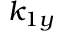<formula> <loc_0><loc_0><loc_500><loc_500>k _ { 1 y }</formula> 